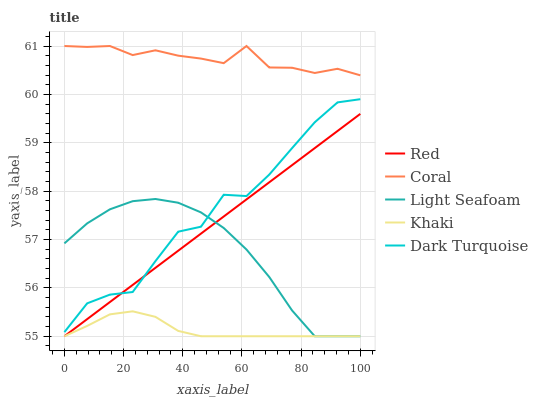Does Khaki have the minimum area under the curve?
Answer yes or no. Yes. Does Coral have the maximum area under the curve?
Answer yes or no. Yes. Does Light Seafoam have the minimum area under the curve?
Answer yes or no. No. Does Light Seafoam have the maximum area under the curve?
Answer yes or no. No. Is Red the smoothest?
Answer yes or no. Yes. Is Dark Turquoise the roughest?
Answer yes or no. Yes. Is Coral the smoothest?
Answer yes or no. No. Is Coral the roughest?
Answer yes or no. No. Does Light Seafoam have the lowest value?
Answer yes or no. Yes. Does Coral have the lowest value?
Answer yes or no. No. Does Coral have the highest value?
Answer yes or no. Yes. Does Light Seafoam have the highest value?
Answer yes or no. No. Is Dark Turquoise less than Coral?
Answer yes or no. Yes. Is Coral greater than Khaki?
Answer yes or no. Yes. Does Red intersect Dark Turquoise?
Answer yes or no. Yes. Is Red less than Dark Turquoise?
Answer yes or no. No. Is Red greater than Dark Turquoise?
Answer yes or no. No. Does Dark Turquoise intersect Coral?
Answer yes or no. No. 